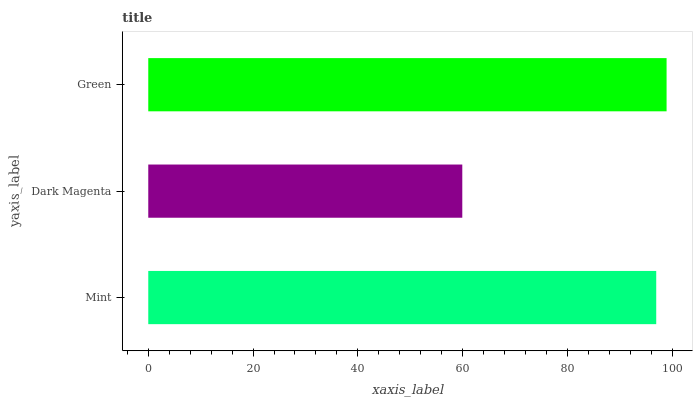Is Dark Magenta the minimum?
Answer yes or no. Yes. Is Green the maximum?
Answer yes or no. Yes. Is Green the minimum?
Answer yes or no. No. Is Dark Magenta the maximum?
Answer yes or no. No. Is Green greater than Dark Magenta?
Answer yes or no. Yes. Is Dark Magenta less than Green?
Answer yes or no. Yes. Is Dark Magenta greater than Green?
Answer yes or no. No. Is Green less than Dark Magenta?
Answer yes or no. No. Is Mint the high median?
Answer yes or no. Yes. Is Mint the low median?
Answer yes or no. Yes. Is Green the high median?
Answer yes or no. No. Is Green the low median?
Answer yes or no. No. 